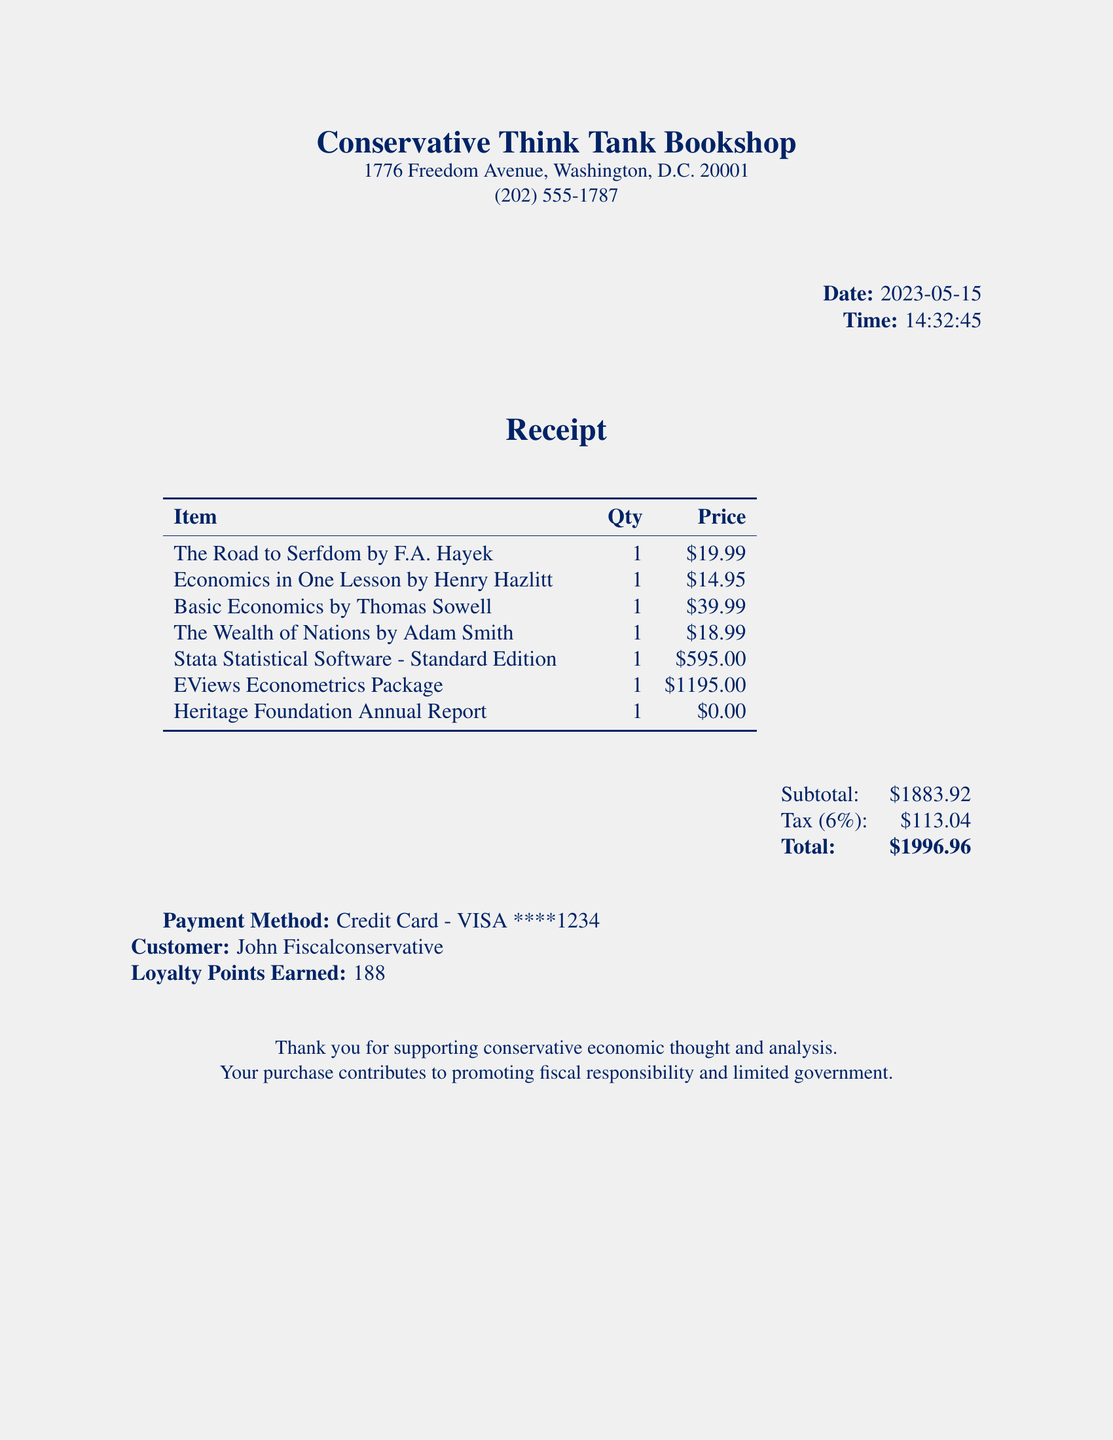What is the store name? The store name is listed at the top of the receipt.
Answer: Conservative Think Tank Bookshop What is the total amount spent? The total is displayed at the bottom of the receipt after tax is added to the subtotal.
Answer: $1996.96 Who is the customer? The customer's name is mentioned at the bottom of the receipt.
Answer: John Fiscalconservative What is the date of the purchase? The date of the purchase is shown in the receipt header.
Answer: 2023-05-15 What is the tax rate applied? The tax rate is provided just before the total section of the receipt.
Answer: 6% How much was spent on software? The prices of the software items can be summed to determine the total spent on them.
Answer: $1790.00 Which item was free? The item listed with a price of zero indicates it was free.
Answer: Heritage Foundation Annual Report What is the quantity of "Basic Economics by Thomas Sowell"? The quantity for each item is specified in the receipt’s itemization table.
Answer: 1 How many loyalty points were earned? The earned loyalty points are found at the bottom of the receipt.
Answer: 188 